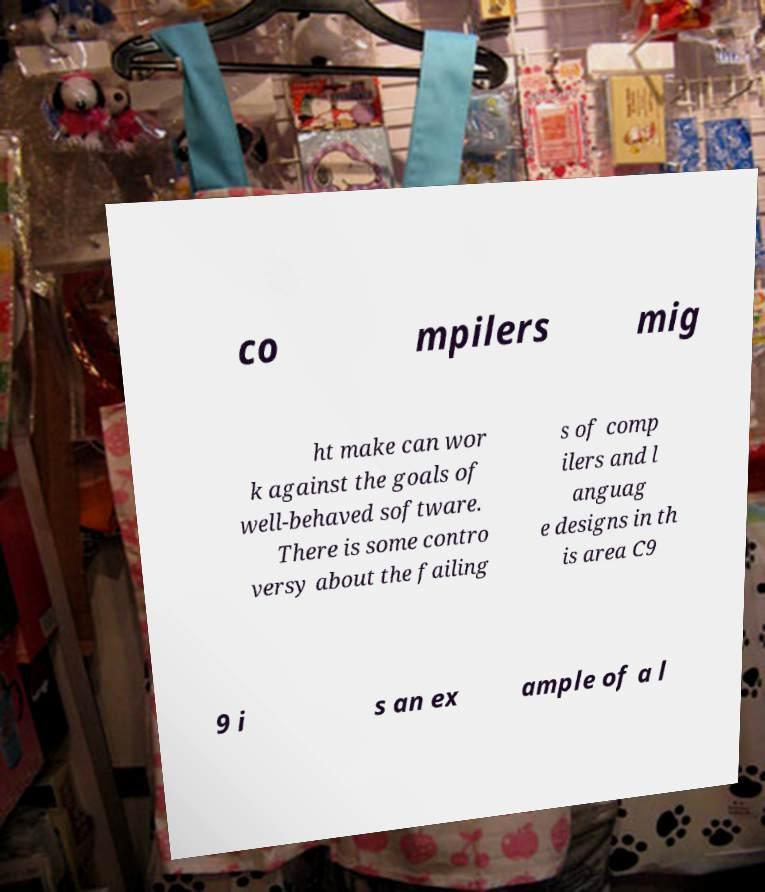There's text embedded in this image that I need extracted. Can you transcribe it verbatim? co mpilers mig ht make can wor k against the goals of well-behaved software. There is some contro versy about the failing s of comp ilers and l anguag e designs in th is area C9 9 i s an ex ample of a l 